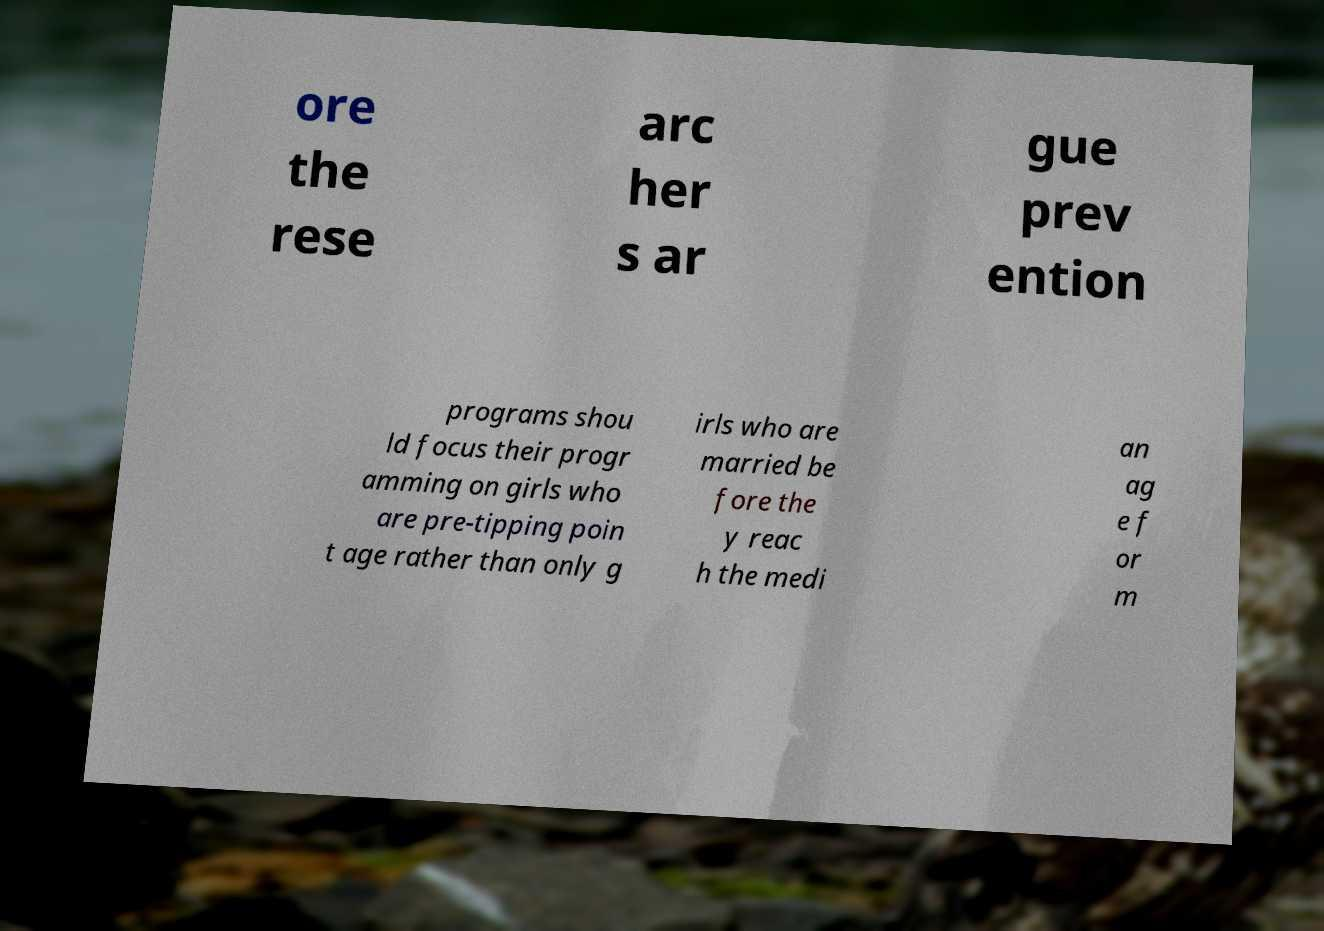I need the written content from this picture converted into text. Can you do that? ore the rese arc her s ar gue prev ention programs shou ld focus their progr amming on girls who are pre-tipping poin t age rather than only g irls who are married be fore the y reac h the medi an ag e f or m 